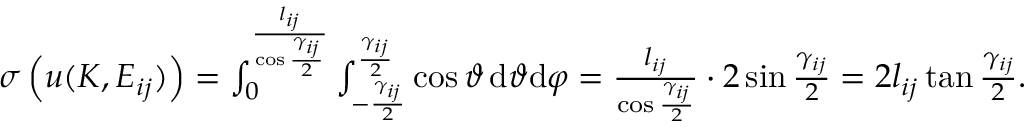<formula> <loc_0><loc_0><loc_500><loc_500>\begin{array} { r } { \sigma \left ( u ( K , E _ { i j } ) \right ) = \int _ { 0 } ^ { \frac { l _ { i j } } { \cos { \frac { \gamma _ { i j } } 2 } } } \int _ { - \frac { \gamma _ { i j } } 2 } ^ { \frac { \gamma _ { i j } } 2 } \cos \vartheta \, d \vartheta d \varphi = \frac { l _ { i j } } { \cos { \frac { \gamma _ { i j } } 2 } } \cdot 2 \sin { \frac { \gamma _ { i j } } 2 } = 2 l _ { i j } \tan { \frac { \gamma _ { i j } } 2 } . } \end{array}</formula> 